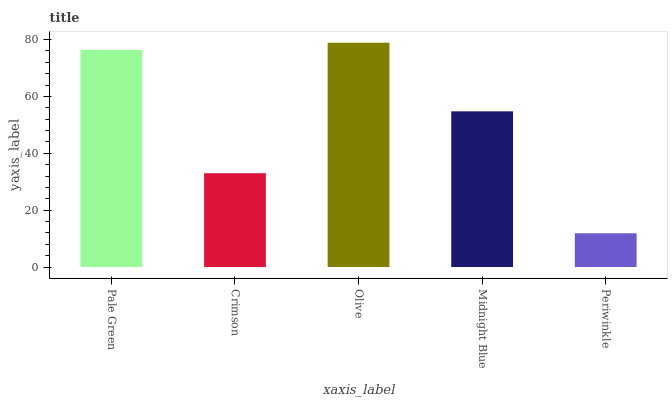Is Periwinkle the minimum?
Answer yes or no. Yes. Is Olive the maximum?
Answer yes or no. Yes. Is Crimson the minimum?
Answer yes or no. No. Is Crimson the maximum?
Answer yes or no. No. Is Pale Green greater than Crimson?
Answer yes or no. Yes. Is Crimson less than Pale Green?
Answer yes or no. Yes. Is Crimson greater than Pale Green?
Answer yes or no. No. Is Pale Green less than Crimson?
Answer yes or no. No. Is Midnight Blue the high median?
Answer yes or no. Yes. Is Midnight Blue the low median?
Answer yes or no. Yes. Is Crimson the high median?
Answer yes or no. No. Is Periwinkle the low median?
Answer yes or no. No. 